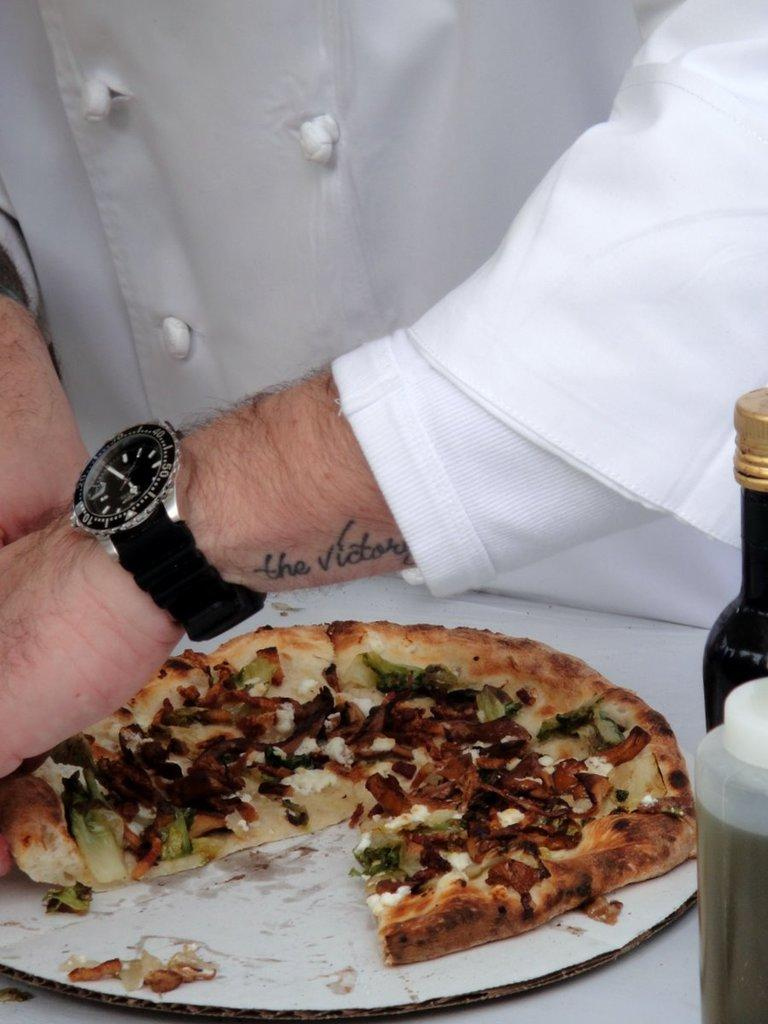What is the main subject in the foreground of the image? There is a pizza on a table in the foreground of the image. What else can be seen on the table? There are two bottles on the right side of the table. Can you describe the man in the background of the image? In the background, there is a man wearing a white dress and a black watch. How many pins are attached to the pizza in the image? There are no pins present in the image; it features a pizza on a table with two bottles and a man in the background. What type of birds can be seen flying in the background of the image? There are no birds visible in the image; it features a pizza on a table with two bottles and a man in the background. 